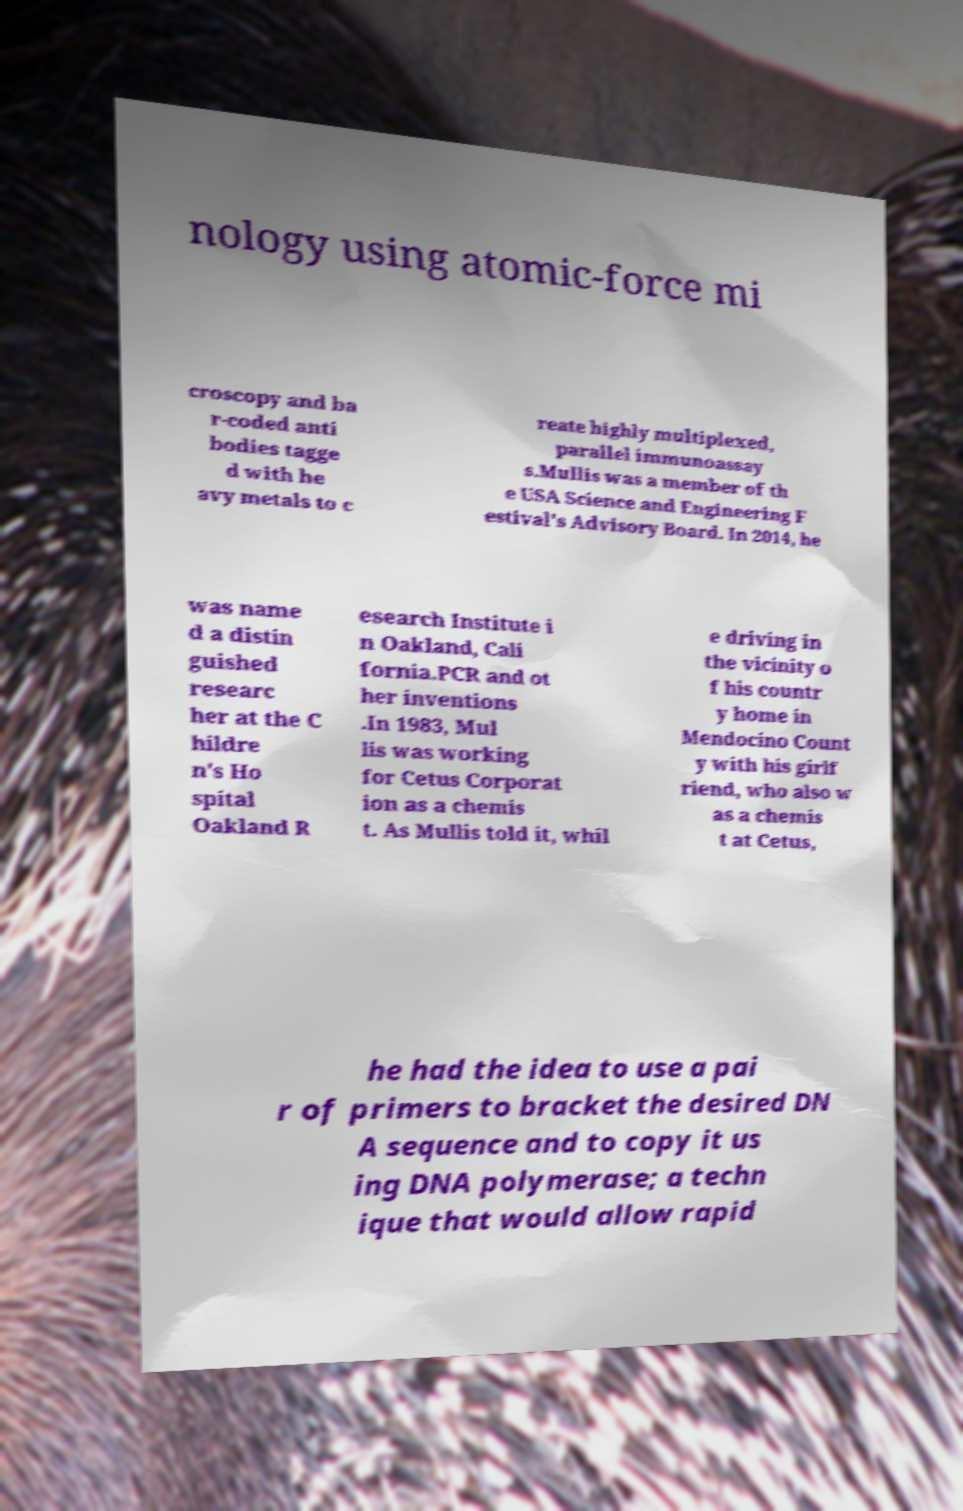What messages or text are displayed in this image? I need them in a readable, typed format. nology using atomic-force mi croscopy and ba r-coded anti bodies tagge d with he avy metals to c reate highly multiplexed, parallel immunoassay s.Mullis was a member of th e USA Science and Engineering F estival's Advisory Board. In 2014, he was name d a distin guished researc her at the C hildre n's Ho spital Oakland R esearch Institute i n Oakland, Cali fornia.PCR and ot her inventions .In 1983, Mul lis was working for Cetus Corporat ion as a chemis t. As Mullis told it, whil e driving in the vicinity o f his countr y home in Mendocino Count y with his girlf riend, who also w as a chemis t at Cetus, he had the idea to use a pai r of primers to bracket the desired DN A sequence and to copy it us ing DNA polymerase; a techn ique that would allow rapid 